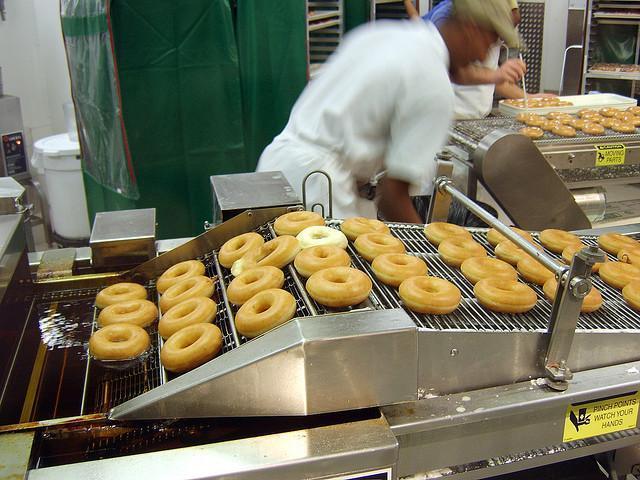How many donuts are in the picture?
Give a very brief answer. 4. How many people can be seen?
Give a very brief answer. 2. 